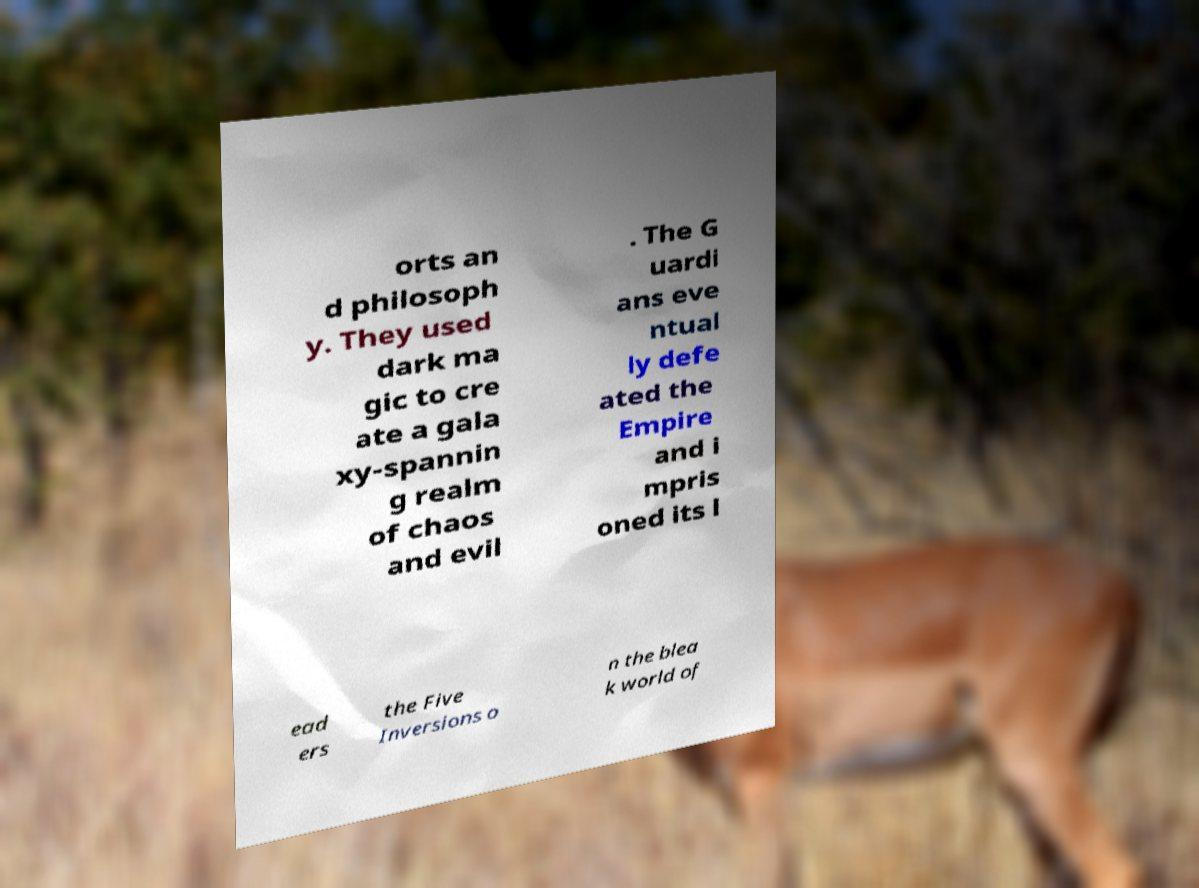Please read and relay the text visible in this image. What does it say? orts an d philosoph y. They used dark ma gic to cre ate a gala xy-spannin g realm of chaos and evil . The G uardi ans eve ntual ly defe ated the Empire and i mpris oned its l ead ers the Five Inversions o n the blea k world of 